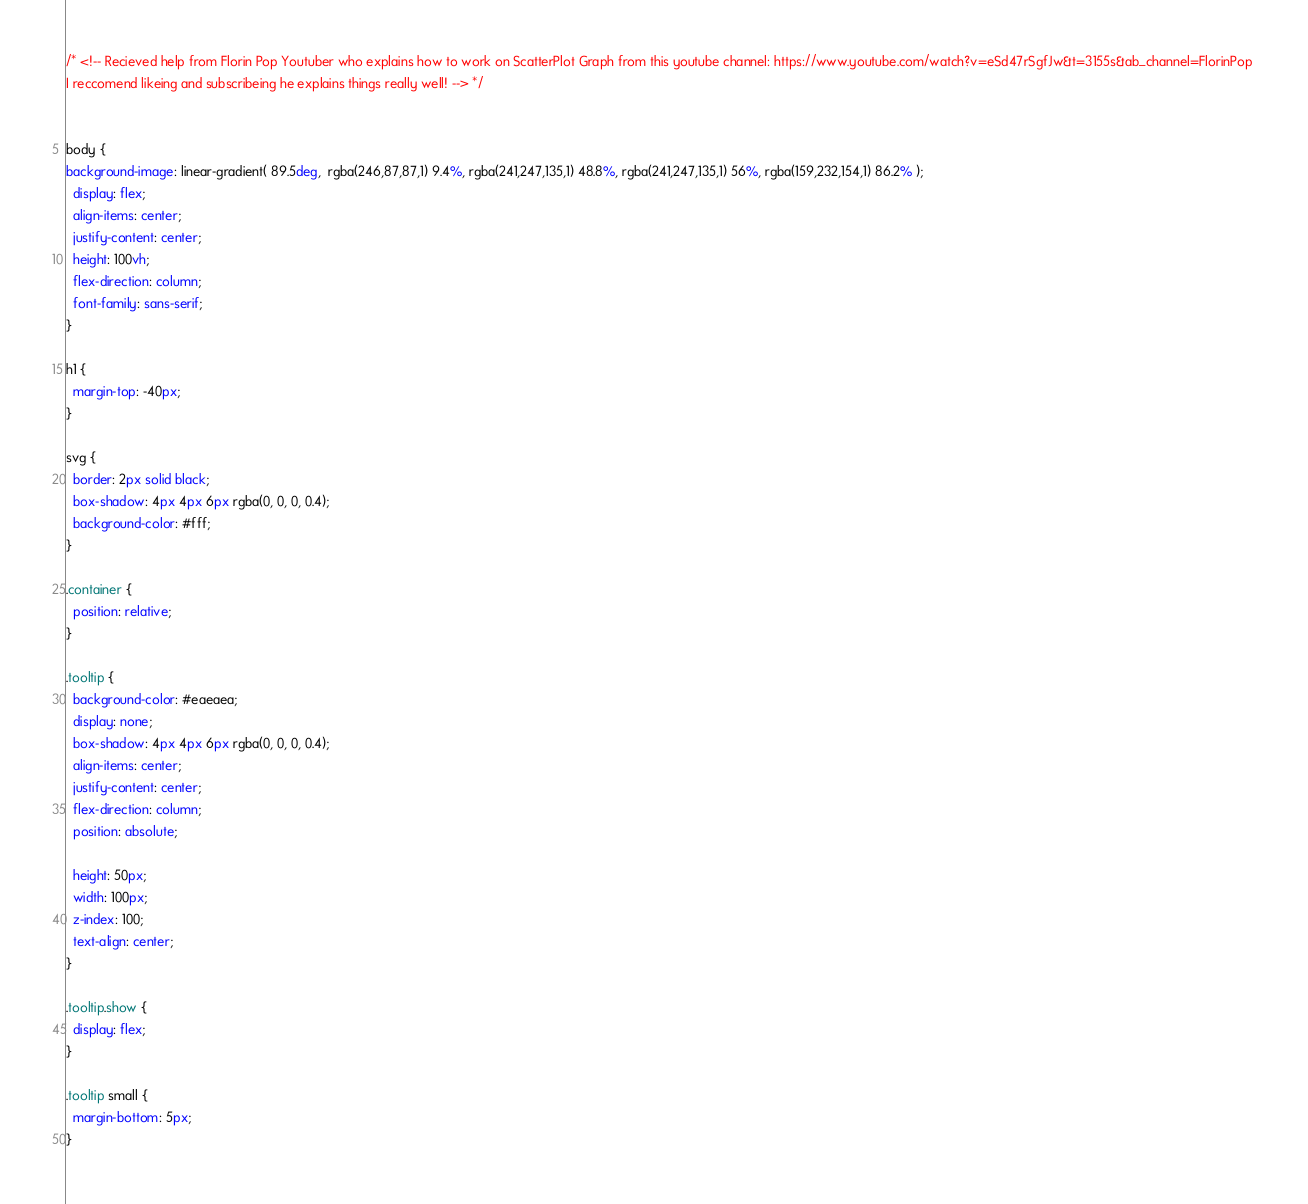<code> <loc_0><loc_0><loc_500><loc_500><_CSS_>/* <!-- Recieved help from Florin Pop Youtuber who explains how to work on ScatterPlot Graph from this youtube channel: https://www.youtube.com/watch?v=eSd47rSgfJw&t=3155s&ab_channel=FlorinPop 
I reccomend likeing and subscribeing he explains things really well! --> */


body {
background-image: linear-gradient( 89.5deg,  rgba(246,87,87,1) 9.4%, rgba(241,247,135,1) 48.8%, rgba(241,247,135,1) 56%, rgba(159,232,154,1) 86.2% );
  display: flex;
  align-items: center;
  justify-content: center;
  height: 100vh;
  flex-direction: column;
  font-family: sans-serif;
}

h1 {
  margin-top: -40px;
}

svg {
  border: 2px solid black;
  box-shadow: 4px 4px 6px rgba(0, 0, 0, 0.4);
  background-color: #fff;
}

.container {
  position: relative;
}

.tooltip {
  background-color: #eaeaea;
  display: none;
  box-shadow: 4px 4px 6px rgba(0, 0, 0, 0.4);
  align-items: center;
  justify-content: center;
  flex-direction: column;
  position: absolute;

  height: 50px;
  width: 100px;
  z-index: 100;
  text-align: center;
}

.tooltip.show {
  display: flex;
}

.tooltip small {
  margin-bottom: 5px;
}</code> 